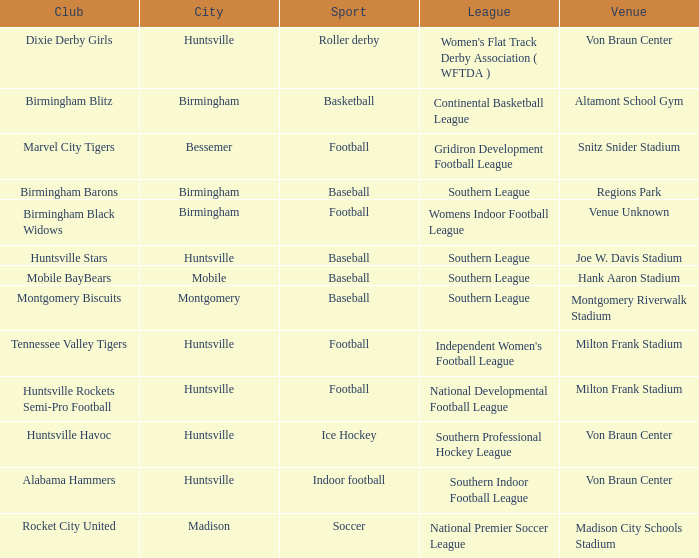Which site hosted the gridiron development football league? Snitz Snider Stadium. 